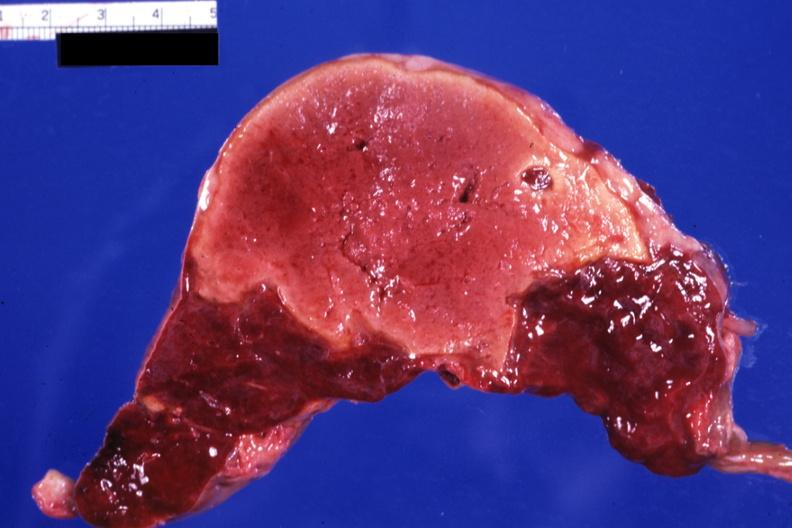does this image show large yellow lesion probably several weeks of age?
Answer the question using a single word or phrase. Yes 